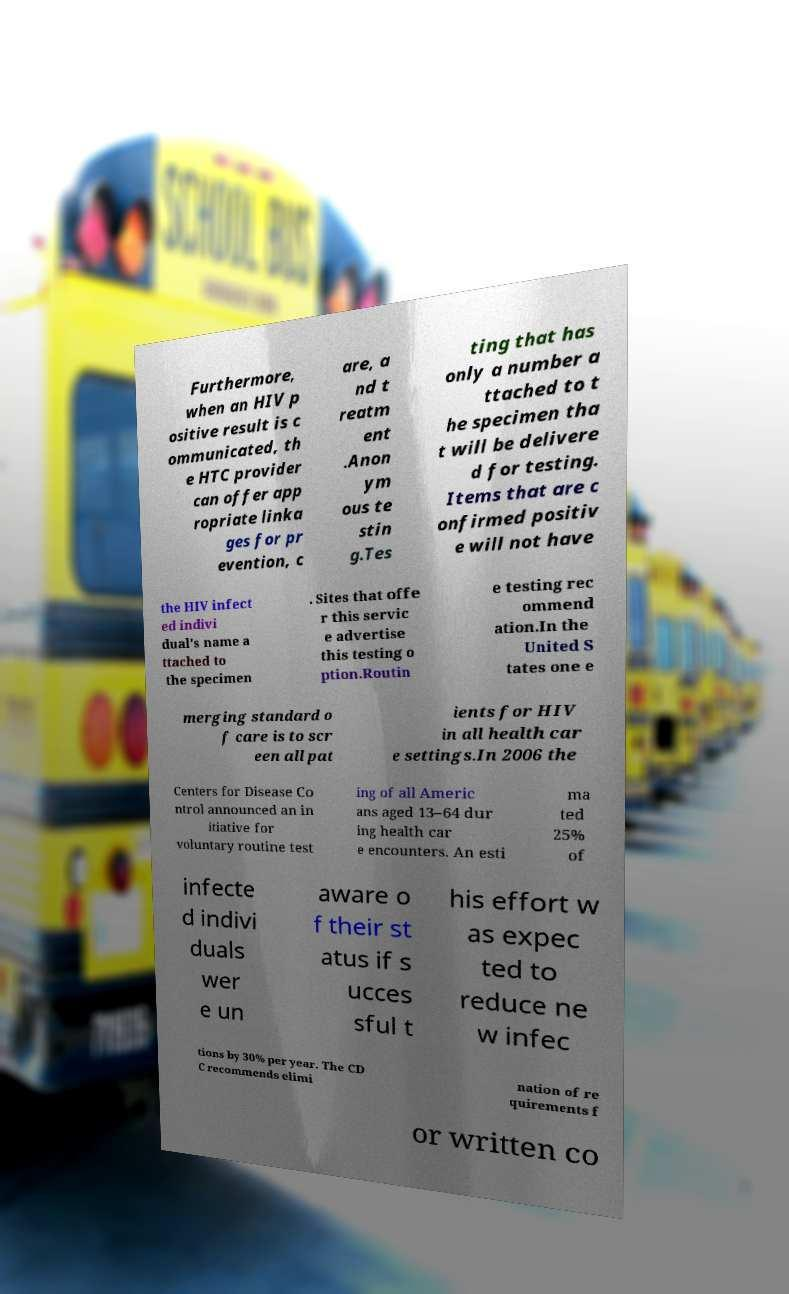I need the written content from this picture converted into text. Can you do that? Furthermore, when an HIV p ositive result is c ommunicated, th e HTC provider can offer app ropriate linka ges for pr evention, c are, a nd t reatm ent .Anon ym ous te stin g.Tes ting that has only a number a ttached to t he specimen tha t will be delivere d for testing. Items that are c onfirmed positiv e will not have the HIV infect ed indivi dual's name a ttached to the specimen . Sites that offe r this servic e advertise this testing o ption.Routin e testing rec ommend ation.In the United S tates one e merging standard o f care is to scr een all pat ients for HIV in all health car e settings.In 2006 the Centers for Disease Co ntrol announced an in itiative for voluntary routine test ing of all Americ ans aged 13–64 dur ing health car e encounters. An esti ma ted 25% of infecte d indivi duals wer e un aware o f their st atus if s ucces sful t his effort w as expec ted to reduce ne w infec tions by 30% per year. The CD C recommends elimi nation of re quirements f or written co 